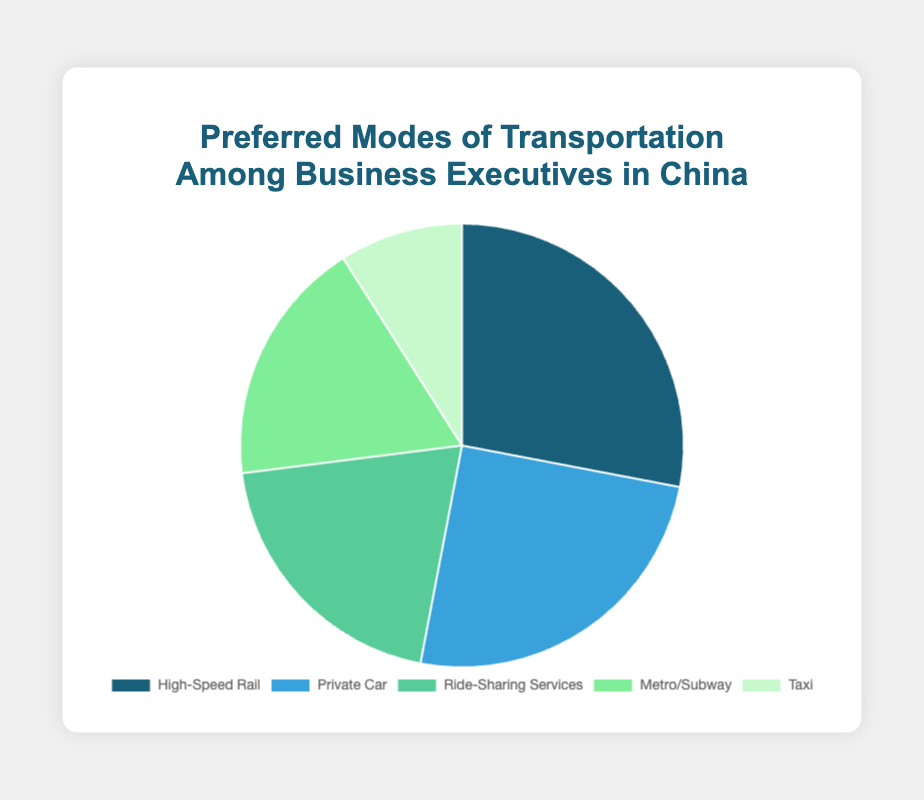Which mode of transportation is preferred the most among business executives in China? The mode with the highest percentage in the pie chart is the most preferred. Here, the "High-Speed Rail" has the highest percentage of 28%.
Answer: High-Speed Rail Which mode of transportation is preferred the least? The mode with the lowest percentage in the pie chart is the least preferred. Here, "Taxi" has the lowest percentage of 9%.
Answer: Taxi What's the combined percentage of executives using private car and metro/subway? Add the percentages of "Private Car" and "Metro/Subway": 25% + 18% = 43%.
Answer: 43% Which two modes of transportation together account for half (50%) of the preferences? Find two modes of transportation whose combined percentages equal 50%, or closest to it. "High-Speed Rail" and "Taxi" combined is 28% + 9% = 37%, which is less than 50%. "Private Car" and "Metro/Subway" combined is 25% + 18% = 43%, still less than 50%. "High-Speed Rail" and "Ride-Sharing Services" combined is 28% + 20% = 48%, closest to 50%.
Answer: High-Speed Rail and Ride-Sharing Services Which mode of transportation has a percentage closest to the average percentage of all modes? Calculate the average percentage: (28% + 25% + 20% + 18% + 9%)/5 = 20%. The "Ride-Sharing Services" has a percentage equal to the average percentage (20%).
Answer: Ride-Sharing Services Is the percentage of business executives using ride-sharing services higher or lower than those using a private car? Compare the percentage of "Ride-Sharing Services" (20%) with "Private Car" (25%). 20% is less than 25%, so it is lower.
Answer: Lower How much higher is the percentage of business executives preferring high-speed rail compared to those preferring taxis? Subtract the percentage of "Taxi" from "High-Speed Rail": 28% - 9% = 19%.
Answer: 19% What two modes of transportation have the closest percentages? The two modes of transportation with the closest percentages are "Metro/Subway" (18%) and "Ride-Sharing Services" (20%). The difference is 2%.
Answer: Metro/Subway and Ride-Sharing Services 